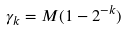<formula> <loc_0><loc_0><loc_500><loc_500>\gamma _ { k } = M ( 1 - 2 ^ { - k } )</formula> 